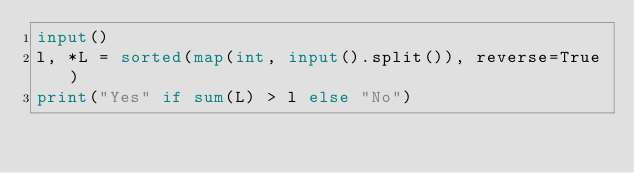Convert code to text. <code><loc_0><loc_0><loc_500><loc_500><_Python_>input()
l, *L = sorted(map(int, input().split()), reverse=True)
print("Yes" if sum(L) > l else "No")
</code> 